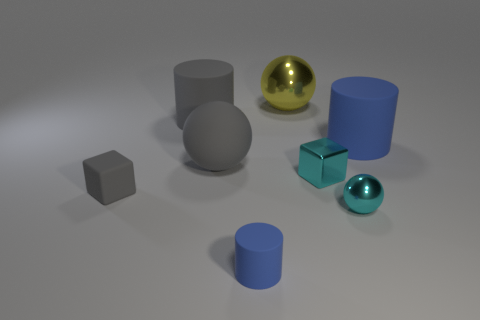There is a cylinder that is the same color as the tiny rubber block; what is its material?
Your answer should be compact. Rubber. How many objects are either large objects that are on the left side of the large yellow metallic object or small matte cubes?
Give a very brief answer. 3. Is there any other thing that has the same size as the gray ball?
Provide a succinct answer. Yes. The cylinder that is left of the big matte ball that is in front of the big blue matte cylinder is made of what material?
Your response must be concise. Rubber. Are there the same number of gray rubber blocks that are behind the yellow metal thing and yellow metal things that are in front of the tiny blue thing?
Make the answer very short. Yes. How many objects are matte cylinders behind the large blue rubber cylinder or small cyan metal things to the left of the tiny cyan metallic sphere?
Give a very brief answer. 2. What is the big thing that is both left of the cyan metal ball and in front of the big gray cylinder made of?
Ensure brevity in your answer.  Rubber. There is a blue cylinder behind the big rubber ball that is behind the blue rubber cylinder in front of the large rubber ball; what size is it?
Provide a short and direct response. Large. Is the number of tiny brown metal objects greater than the number of blue objects?
Give a very brief answer. No. Are the big thing on the right side of the cyan shiny cube and the gray cube made of the same material?
Offer a terse response. Yes. 